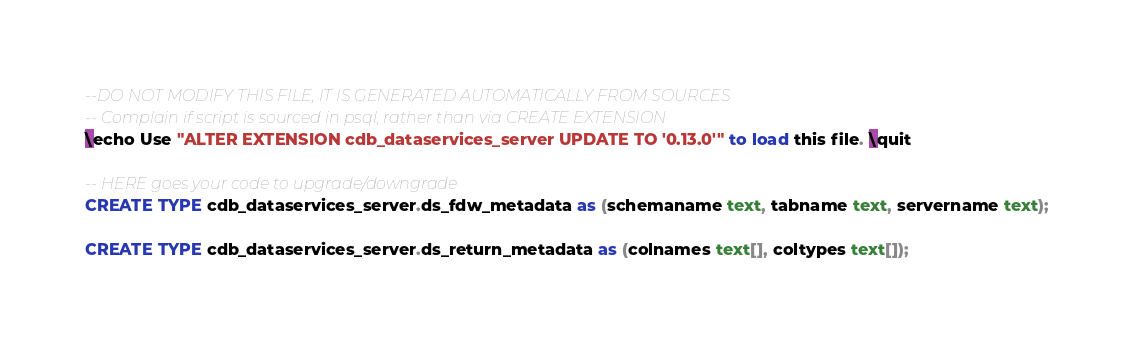Convert code to text. <code><loc_0><loc_0><loc_500><loc_500><_SQL_>--DO NOT MODIFY THIS FILE, IT IS GENERATED AUTOMATICALLY FROM SOURCES
-- Complain if script is sourced in psql, rather than via CREATE EXTENSION
\echo Use "ALTER EXTENSION cdb_dataservices_server UPDATE TO '0.13.0'" to load this file. \quit

-- HERE goes your code to upgrade/downgrade
CREATE TYPE cdb_dataservices_server.ds_fdw_metadata as (schemaname text, tabname text, servername text);

CREATE TYPE cdb_dataservices_server.ds_return_metadata as (colnames text[], coltypes text[]);
</code> 